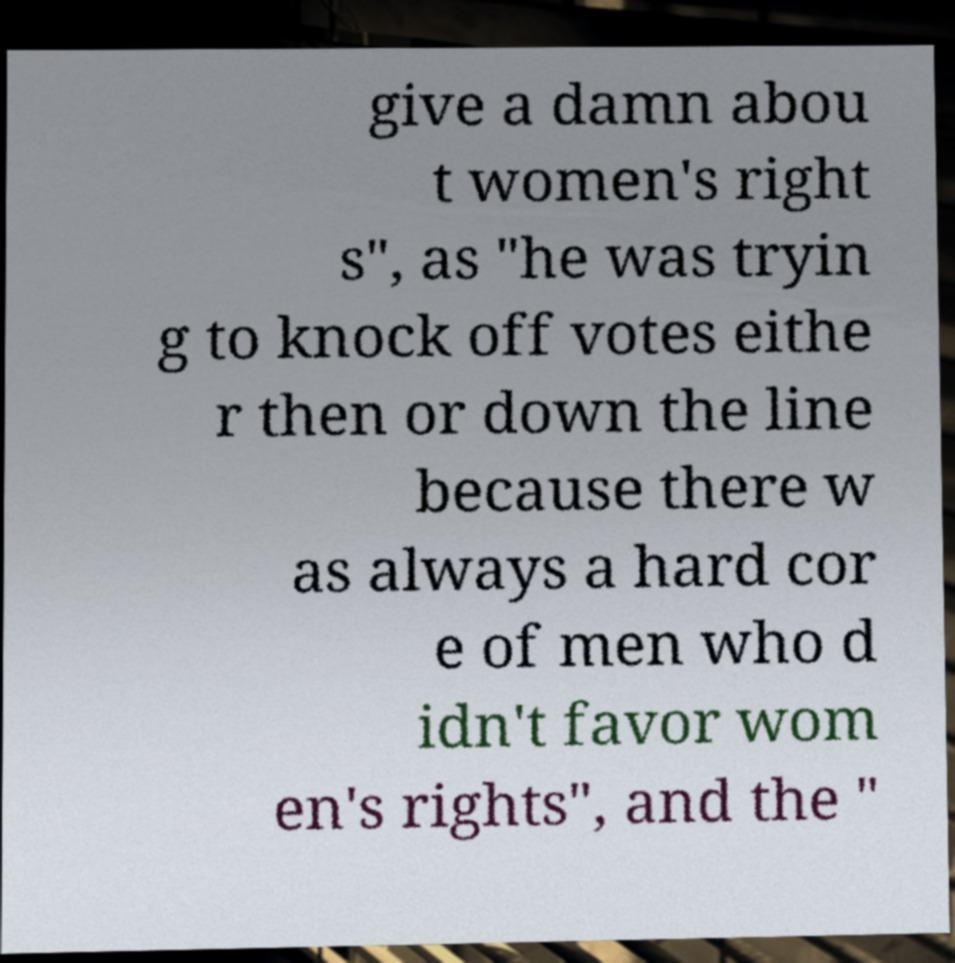For documentation purposes, I need the text within this image transcribed. Could you provide that? give a damn abou t women's right s", as "he was tryin g to knock off votes eithe r then or down the line because there w as always a hard cor e of men who d idn't favor wom en's rights", and the " 